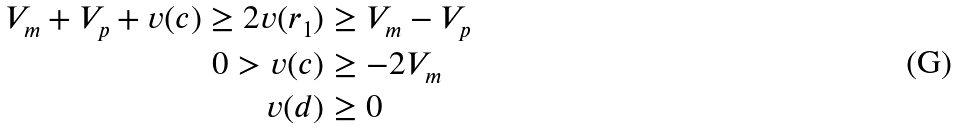Convert formula to latex. <formula><loc_0><loc_0><loc_500><loc_500>V _ { m } + V _ { p } + v ( c ) \geq 2 v ( r _ { 1 } ) & \geq V _ { m } - V _ { p } \\ 0 > v ( c ) & \geq - 2 V _ { m } \\ v ( d ) & \geq 0</formula> 